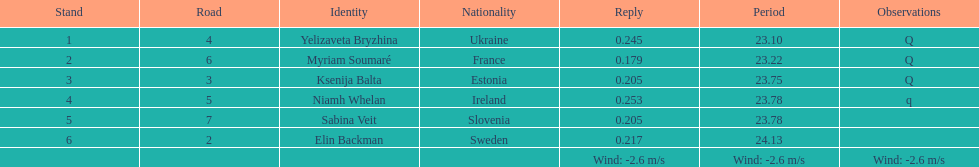What number of last names start with "b"? 3. 